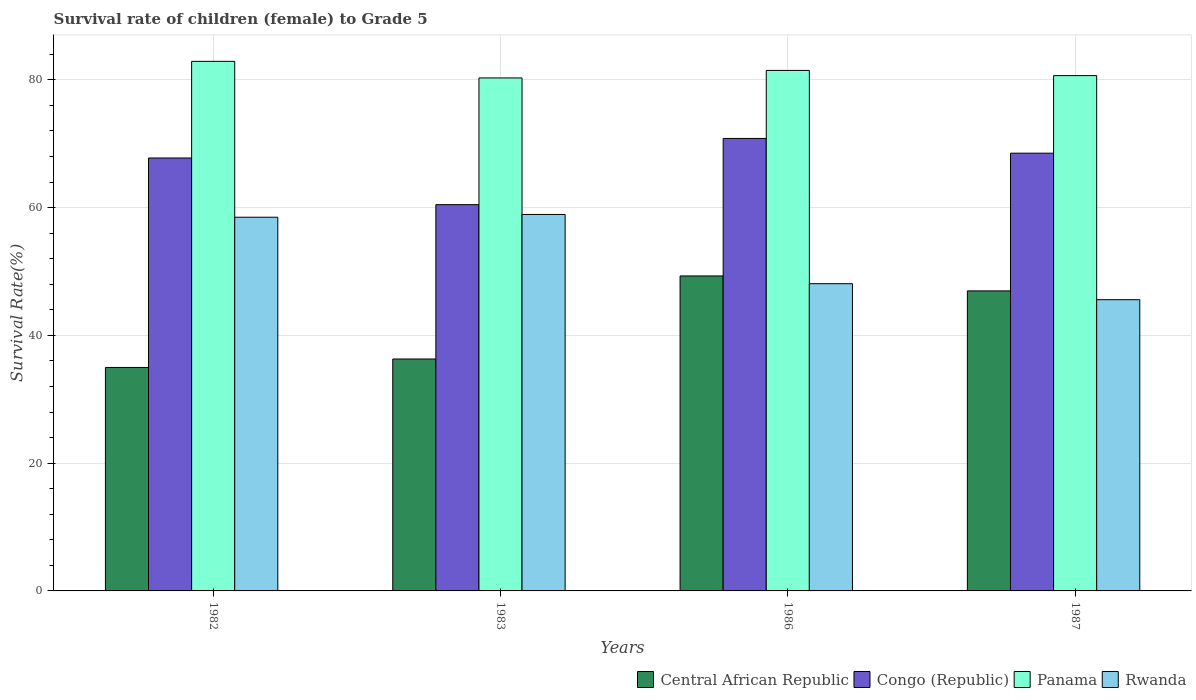How many groups of bars are there?
Ensure brevity in your answer.  4. How many bars are there on the 3rd tick from the right?
Your response must be concise. 4. What is the label of the 3rd group of bars from the left?
Provide a short and direct response. 1986. What is the survival rate of female children to grade 5 in Panama in 1983?
Provide a succinct answer. 80.3. Across all years, what is the maximum survival rate of female children to grade 5 in Panama?
Provide a short and direct response. 82.9. Across all years, what is the minimum survival rate of female children to grade 5 in Rwanda?
Ensure brevity in your answer.  45.59. In which year was the survival rate of female children to grade 5 in Central African Republic maximum?
Ensure brevity in your answer.  1986. In which year was the survival rate of female children to grade 5 in Panama minimum?
Your answer should be very brief. 1983. What is the total survival rate of female children to grade 5 in Rwanda in the graph?
Keep it short and to the point. 211.11. What is the difference between the survival rate of female children to grade 5 in Central African Republic in 1982 and that in 1987?
Offer a terse response. -11.99. What is the difference between the survival rate of female children to grade 5 in Congo (Republic) in 1986 and the survival rate of female children to grade 5 in Panama in 1982?
Your answer should be compact. -12.07. What is the average survival rate of female children to grade 5 in Rwanda per year?
Give a very brief answer. 52.78. In the year 1983, what is the difference between the survival rate of female children to grade 5 in Panama and survival rate of female children to grade 5 in Central African Republic?
Your answer should be compact. 44. In how many years, is the survival rate of female children to grade 5 in Congo (Republic) greater than 60 %?
Provide a succinct answer. 4. What is the ratio of the survival rate of female children to grade 5 in Panama in 1986 to that in 1987?
Offer a very short reply. 1.01. Is the survival rate of female children to grade 5 in Central African Republic in 1983 less than that in 1987?
Ensure brevity in your answer.  Yes. What is the difference between the highest and the second highest survival rate of female children to grade 5 in Congo (Republic)?
Your answer should be very brief. 2.31. What is the difference between the highest and the lowest survival rate of female children to grade 5 in Panama?
Provide a succinct answer. 2.6. In how many years, is the survival rate of female children to grade 5 in Rwanda greater than the average survival rate of female children to grade 5 in Rwanda taken over all years?
Provide a succinct answer. 2. Is the sum of the survival rate of female children to grade 5 in Central African Republic in 1982 and 1983 greater than the maximum survival rate of female children to grade 5 in Rwanda across all years?
Your answer should be very brief. Yes. What does the 3rd bar from the left in 1987 represents?
Provide a succinct answer. Panama. What does the 3rd bar from the right in 1983 represents?
Keep it short and to the point. Congo (Republic). Is it the case that in every year, the sum of the survival rate of female children to grade 5 in Panama and survival rate of female children to grade 5 in Rwanda is greater than the survival rate of female children to grade 5 in Central African Republic?
Give a very brief answer. Yes. How many bars are there?
Your answer should be very brief. 16. How many years are there in the graph?
Provide a succinct answer. 4. What is the difference between two consecutive major ticks on the Y-axis?
Provide a succinct answer. 20. Does the graph contain grids?
Your answer should be compact. Yes. Where does the legend appear in the graph?
Provide a succinct answer. Bottom right. What is the title of the graph?
Provide a succinct answer. Survival rate of children (female) to Grade 5. Does "Equatorial Guinea" appear as one of the legend labels in the graph?
Offer a very short reply. No. What is the label or title of the Y-axis?
Provide a succinct answer. Survival Rate(%). What is the Survival Rate(%) of Central African Republic in 1982?
Offer a terse response. 34.98. What is the Survival Rate(%) of Congo (Republic) in 1982?
Offer a terse response. 67.77. What is the Survival Rate(%) in Panama in 1982?
Your answer should be very brief. 82.9. What is the Survival Rate(%) of Rwanda in 1982?
Give a very brief answer. 58.5. What is the Survival Rate(%) in Central African Republic in 1983?
Provide a short and direct response. 36.31. What is the Survival Rate(%) of Congo (Republic) in 1983?
Provide a short and direct response. 60.47. What is the Survival Rate(%) in Panama in 1983?
Provide a succinct answer. 80.3. What is the Survival Rate(%) in Rwanda in 1983?
Give a very brief answer. 58.93. What is the Survival Rate(%) of Central African Republic in 1986?
Your response must be concise. 49.31. What is the Survival Rate(%) of Congo (Republic) in 1986?
Your answer should be compact. 70.83. What is the Survival Rate(%) in Panama in 1986?
Your response must be concise. 81.48. What is the Survival Rate(%) in Rwanda in 1986?
Your answer should be compact. 48.09. What is the Survival Rate(%) of Central African Republic in 1987?
Provide a succinct answer. 46.97. What is the Survival Rate(%) in Congo (Republic) in 1987?
Offer a very short reply. 68.53. What is the Survival Rate(%) of Panama in 1987?
Offer a terse response. 80.67. What is the Survival Rate(%) of Rwanda in 1987?
Ensure brevity in your answer.  45.59. Across all years, what is the maximum Survival Rate(%) of Central African Republic?
Give a very brief answer. 49.31. Across all years, what is the maximum Survival Rate(%) of Congo (Republic)?
Ensure brevity in your answer.  70.83. Across all years, what is the maximum Survival Rate(%) in Panama?
Offer a terse response. 82.9. Across all years, what is the maximum Survival Rate(%) in Rwanda?
Provide a short and direct response. 58.93. Across all years, what is the minimum Survival Rate(%) of Central African Republic?
Provide a succinct answer. 34.98. Across all years, what is the minimum Survival Rate(%) of Congo (Republic)?
Your response must be concise. 60.47. Across all years, what is the minimum Survival Rate(%) of Panama?
Your answer should be compact. 80.3. Across all years, what is the minimum Survival Rate(%) in Rwanda?
Offer a very short reply. 45.59. What is the total Survival Rate(%) in Central African Republic in the graph?
Your answer should be compact. 167.57. What is the total Survival Rate(%) of Congo (Republic) in the graph?
Your answer should be compact. 267.6. What is the total Survival Rate(%) in Panama in the graph?
Keep it short and to the point. 325.35. What is the total Survival Rate(%) of Rwanda in the graph?
Ensure brevity in your answer.  211.11. What is the difference between the Survival Rate(%) in Central African Republic in 1982 and that in 1983?
Ensure brevity in your answer.  -1.32. What is the difference between the Survival Rate(%) in Congo (Republic) in 1982 and that in 1983?
Your answer should be compact. 7.3. What is the difference between the Survival Rate(%) of Panama in 1982 and that in 1983?
Offer a very short reply. 2.6. What is the difference between the Survival Rate(%) in Rwanda in 1982 and that in 1983?
Ensure brevity in your answer.  -0.43. What is the difference between the Survival Rate(%) in Central African Republic in 1982 and that in 1986?
Offer a very short reply. -14.32. What is the difference between the Survival Rate(%) of Congo (Republic) in 1982 and that in 1986?
Provide a short and direct response. -3.06. What is the difference between the Survival Rate(%) in Panama in 1982 and that in 1986?
Provide a short and direct response. 1.42. What is the difference between the Survival Rate(%) of Rwanda in 1982 and that in 1986?
Offer a terse response. 10.4. What is the difference between the Survival Rate(%) in Central African Republic in 1982 and that in 1987?
Offer a terse response. -11.99. What is the difference between the Survival Rate(%) of Congo (Republic) in 1982 and that in 1987?
Ensure brevity in your answer.  -0.75. What is the difference between the Survival Rate(%) of Panama in 1982 and that in 1987?
Give a very brief answer. 2.23. What is the difference between the Survival Rate(%) of Rwanda in 1982 and that in 1987?
Keep it short and to the point. 12.91. What is the difference between the Survival Rate(%) in Central African Republic in 1983 and that in 1986?
Give a very brief answer. -13. What is the difference between the Survival Rate(%) in Congo (Republic) in 1983 and that in 1986?
Offer a terse response. -10.36. What is the difference between the Survival Rate(%) in Panama in 1983 and that in 1986?
Keep it short and to the point. -1.18. What is the difference between the Survival Rate(%) of Rwanda in 1983 and that in 1986?
Make the answer very short. 10.84. What is the difference between the Survival Rate(%) of Central African Republic in 1983 and that in 1987?
Provide a short and direct response. -10.66. What is the difference between the Survival Rate(%) of Congo (Republic) in 1983 and that in 1987?
Keep it short and to the point. -8.06. What is the difference between the Survival Rate(%) in Panama in 1983 and that in 1987?
Keep it short and to the point. -0.37. What is the difference between the Survival Rate(%) of Rwanda in 1983 and that in 1987?
Provide a short and direct response. 13.34. What is the difference between the Survival Rate(%) of Central African Republic in 1986 and that in 1987?
Offer a terse response. 2.34. What is the difference between the Survival Rate(%) of Congo (Republic) in 1986 and that in 1987?
Your answer should be compact. 2.31. What is the difference between the Survival Rate(%) in Panama in 1986 and that in 1987?
Give a very brief answer. 0.81. What is the difference between the Survival Rate(%) in Rwanda in 1986 and that in 1987?
Your response must be concise. 2.51. What is the difference between the Survival Rate(%) of Central African Republic in 1982 and the Survival Rate(%) of Congo (Republic) in 1983?
Your answer should be compact. -25.49. What is the difference between the Survival Rate(%) of Central African Republic in 1982 and the Survival Rate(%) of Panama in 1983?
Offer a very short reply. -45.32. What is the difference between the Survival Rate(%) in Central African Republic in 1982 and the Survival Rate(%) in Rwanda in 1983?
Give a very brief answer. -23.95. What is the difference between the Survival Rate(%) of Congo (Republic) in 1982 and the Survival Rate(%) of Panama in 1983?
Your answer should be very brief. -12.53. What is the difference between the Survival Rate(%) in Congo (Republic) in 1982 and the Survival Rate(%) in Rwanda in 1983?
Keep it short and to the point. 8.84. What is the difference between the Survival Rate(%) in Panama in 1982 and the Survival Rate(%) in Rwanda in 1983?
Your answer should be very brief. 23.97. What is the difference between the Survival Rate(%) in Central African Republic in 1982 and the Survival Rate(%) in Congo (Republic) in 1986?
Your response must be concise. -35.85. What is the difference between the Survival Rate(%) of Central African Republic in 1982 and the Survival Rate(%) of Panama in 1986?
Offer a terse response. -46.5. What is the difference between the Survival Rate(%) of Central African Republic in 1982 and the Survival Rate(%) of Rwanda in 1986?
Offer a terse response. -13.11. What is the difference between the Survival Rate(%) in Congo (Republic) in 1982 and the Survival Rate(%) in Panama in 1986?
Provide a short and direct response. -13.71. What is the difference between the Survival Rate(%) in Congo (Republic) in 1982 and the Survival Rate(%) in Rwanda in 1986?
Provide a short and direct response. 19.68. What is the difference between the Survival Rate(%) of Panama in 1982 and the Survival Rate(%) of Rwanda in 1986?
Make the answer very short. 34.81. What is the difference between the Survival Rate(%) in Central African Republic in 1982 and the Survival Rate(%) in Congo (Republic) in 1987?
Provide a succinct answer. -33.54. What is the difference between the Survival Rate(%) in Central African Republic in 1982 and the Survival Rate(%) in Panama in 1987?
Give a very brief answer. -45.68. What is the difference between the Survival Rate(%) in Central African Republic in 1982 and the Survival Rate(%) in Rwanda in 1987?
Offer a terse response. -10.61. What is the difference between the Survival Rate(%) in Congo (Republic) in 1982 and the Survival Rate(%) in Panama in 1987?
Give a very brief answer. -12.89. What is the difference between the Survival Rate(%) in Congo (Republic) in 1982 and the Survival Rate(%) in Rwanda in 1987?
Offer a very short reply. 22.18. What is the difference between the Survival Rate(%) in Panama in 1982 and the Survival Rate(%) in Rwanda in 1987?
Your answer should be compact. 37.31. What is the difference between the Survival Rate(%) in Central African Republic in 1983 and the Survival Rate(%) in Congo (Republic) in 1986?
Make the answer very short. -34.53. What is the difference between the Survival Rate(%) of Central African Republic in 1983 and the Survival Rate(%) of Panama in 1986?
Your answer should be very brief. -45.18. What is the difference between the Survival Rate(%) of Central African Republic in 1983 and the Survival Rate(%) of Rwanda in 1986?
Keep it short and to the point. -11.79. What is the difference between the Survival Rate(%) in Congo (Republic) in 1983 and the Survival Rate(%) in Panama in 1986?
Provide a short and direct response. -21.01. What is the difference between the Survival Rate(%) in Congo (Republic) in 1983 and the Survival Rate(%) in Rwanda in 1986?
Offer a very short reply. 12.37. What is the difference between the Survival Rate(%) in Panama in 1983 and the Survival Rate(%) in Rwanda in 1986?
Provide a succinct answer. 32.21. What is the difference between the Survival Rate(%) in Central African Republic in 1983 and the Survival Rate(%) in Congo (Republic) in 1987?
Offer a terse response. -32.22. What is the difference between the Survival Rate(%) of Central African Republic in 1983 and the Survival Rate(%) of Panama in 1987?
Provide a short and direct response. -44.36. What is the difference between the Survival Rate(%) of Central African Republic in 1983 and the Survival Rate(%) of Rwanda in 1987?
Offer a very short reply. -9.28. What is the difference between the Survival Rate(%) of Congo (Republic) in 1983 and the Survival Rate(%) of Panama in 1987?
Offer a terse response. -20.2. What is the difference between the Survival Rate(%) of Congo (Republic) in 1983 and the Survival Rate(%) of Rwanda in 1987?
Your answer should be compact. 14.88. What is the difference between the Survival Rate(%) of Panama in 1983 and the Survival Rate(%) of Rwanda in 1987?
Provide a short and direct response. 34.71. What is the difference between the Survival Rate(%) of Central African Republic in 1986 and the Survival Rate(%) of Congo (Republic) in 1987?
Give a very brief answer. -19.22. What is the difference between the Survival Rate(%) of Central African Republic in 1986 and the Survival Rate(%) of Panama in 1987?
Ensure brevity in your answer.  -31.36. What is the difference between the Survival Rate(%) in Central African Republic in 1986 and the Survival Rate(%) in Rwanda in 1987?
Ensure brevity in your answer.  3.72. What is the difference between the Survival Rate(%) in Congo (Republic) in 1986 and the Survival Rate(%) in Panama in 1987?
Offer a terse response. -9.84. What is the difference between the Survival Rate(%) of Congo (Republic) in 1986 and the Survival Rate(%) of Rwanda in 1987?
Ensure brevity in your answer.  25.24. What is the difference between the Survival Rate(%) of Panama in 1986 and the Survival Rate(%) of Rwanda in 1987?
Give a very brief answer. 35.89. What is the average Survival Rate(%) of Central African Republic per year?
Offer a terse response. 41.89. What is the average Survival Rate(%) of Congo (Republic) per year?
Ensure brevity in your answer.  66.9. What is the average Survival Rate(%) of Panama per year?
Provide a short and direct response. 81.34. What is the average Survival Rate(%) in Rwanda per year?
Offer a terse response. 52.78. In the year 1982, what is the difference between the Survival Rate(%) of Central African Republic and Survival Rate(%) of Congo (Republic)?
Provide a succinct answer. -32.79. In the year 1982, what is the difference between the Survival Rate(%) of Central African Republic and Survival Rate(%) of Panama?
Offer a terse response. -47.92. In the year 1982, what is the difference between the Survival Rate(%) of Central African Republic and Survival Rate(%) of Rwanda?
Provide a succinct answer. -23.52. In the year 1982, what is the difference between the Survival Rate(%) of Congo (Republic) and Survival Rate(%) of Panama?
Your answer should be compact. -15.13. In the year 1982, what is the difference between the Survival Rate(%) of Congo (Republic) and Survival Rate(%) of Rwanda?
Give a very brief answer. 9.27. In the year 1982, what is the difference between the Survival Rate(%) in Panama and Survival Rate(%) in Rwanda?
Offer a terse response. 24.4. In the year 1983, what is the difference between the Survival Rate(%) in Central African Republic and Survival Rate(%) in Congo (Republic)?
Your response must be concise. -24.16. In the year 1983, what is the difference between the Survival Rate(%) of Central African Republic and Survival Rate(%) of Panama?
Offer a very short reply. -44. In the year 1983, what is the difference between the Survival Rate(%) of Central African Republic and Survival Rate(%) of Rwanda?
Ensure brevity in your answer.  -22.62. In the year 1983, what is the difference between the Survival Rate(%) of Congo (Republic) and Survival Rate(%) of Panama?
Ensure brevity in your answer.  -19.83. In the year 1983, what is the difference between the Survival Rate(%) in Congo (Republic) and Survival Rate(%) in Rwanda?
Keep it short and to the point. 1.54. In the year 1983, what is the difference between the Survival Rate(%) of Panama and Survival Rate(%) of Rwanda?
Offer a very short reply. 21.37. In the year 1986, what is the difference between the Survival Rate(%) in Central African Republic and Survival Rate(%) in Congo (Republic)?
Keep it short and to the point. -21.52. In the year 1986, what is the difference between the Survival Rate(%) of Central African Republic and Survival Rate(%) of Panama?
Offer a terse response. -32.17. In the year 1986, what is the difference between the Survival Rate(%) in Central African Republic and Survival Rate(%) in Rwanda?
Make the answer very short. 1.21. In the year 1986, what is the difference between the Survival Rate(%) in Congo (Republic) and Survival Rate(%) in Panama?
Offer a terse response. -10.65. In the year 1986, what is the difference between the Survival Rate(%) in Congo (Republic) and Survival Rate(%) in Rwanda?
Keep it short and to the point. 22.74. In the year 1986, what is the difference between the Survival Rate(%) of Panama and Survival Rate(%) of Rwanda?
Keep it short and to the point. 33.39. In the year 1987, what is the difference between the Survival Rate(%) in Central African Republic and Survival Rate(%) in Congo (Republic)?
Provide a succinct answer. -21.56. In the year 1987, what is the difference between the Survival Rate(%) of Central African Republic and Survival Rate(%) of Panama?
Your answer should be very brief. -33.7. In the year 1987, what is the difference between the Survival Rate(%) of Central African Republic and Survival Rate(%) of Rwanda?
Your answer should be compact. 1.38. In the year 1987, what is the difference between the Survival Rate(%) of Congo (Republic) and Survival Rate(%) of Panama?
Make the answer very short. -12.14. In the year 1987, what is the difference between the Survival Rate(%) in Congo (Republic) and Survival Rate(%) in Rwanda?
Make the answer very short. 22.94. In the year 1987, what is the difference between the Survival Rate(%) of Panama and Survival Rate(%) of Rwanda?
Provide a short and direct response. 35.08. What is the ratio of the Survival Rate(%) in Central African Republic in 1982 to that in 1983?
Provide a succinct answer. 0.96. What is the ratio of the Survival Rate(%) of Congo (Republic) in 1982 to that in 1983?
Your answer should be compact. 1.12. What is the ratio of the Survival Rate(%) in Panama in 1982 to that in 1983?
Make the answer very short. 1.03. What is the ratio of the Survival Rate(%) of Central African Republic in 1982 to that in 1986?
Keep it short and to the point. 0.71. What is the ratio of the Survival Rate(%) of Congo (Republic) in 1982 to that in 1986?
Ensure brevity in your answer.  0.96. What is the ratio of the Survival Rate(%) in Panama in 1982 to that in 1986?
Keep it short and to the point. 1.02. What is the ratio of the Survival Rate(%) in Rwanda in 1982 to that in 1986?
Make the answer very short. 1.22. What is the ratio of the Survival Rate(%) of Central African Republic in 1982 to that in 1987?
Keep it short and to the point. 0.74. What is the ratio of the Survival Rate(%) of Congo (Republic) in 1982 to that in 1987?
Provide a short and direct response. 0.99. What is the ratio of the Survival Rate(%) of Panama in 1982 to that in 1987?
Your answer should be compact. 1.03. What is the ratio of the Survival Rate(%) in Rwanda in 1982 to that in 1987?
Keep it short and to the point. 1.28. What is the ratio of the Survival Rate(%) in Central African Republic in 1983 to that in 1986?
Your response must be concise. 0.74. What is the ratio of the Survival Rate(%) of Congo (Republic) in 1983 to that in 1986?
Offer a terse response. 0.85. What is the ratio of the Survival Rate(%) in Panama in 1983 to that in 1986?
Your response must be concise. 0.99. What is the ratio of the Survival Rate(%) of Rwanda in 1983 to that in 1986?
Offer a terse response. 1.23. What is the ratio of the Survival Rate(%) of Central African Republic in 1983 to that in 1987?
Keep it short and to the point. 0.77. What is the ratio of the Survival Rate(%) in Congo (Republic) in 1983 to that in 1987?
Offer a very short reply. 0.88. What is the ratio of the Survival Rate(%) in Panama in 1983 to that in 1987?
Your answer should be compact. 1. What is the ratio of the Survival Rate(%) of Rwanda in 1983 to that in 1987?
Provide a succinct answer. 1.29. What is the ratio of the Survival Rate(%) of Central African Republic in 1986 to that in 1987?
Ensure brevity in your answer.  1.05. What is the ratio of the Survival Rate(%) of Congo (Republic) in 1986 to that in 1987?
Keep it short and to the point. 1.03. What is the ratio of the Survival Rate(%) of Panama in 1986 to that in 1987?
Make the answer very short. 1.01. What is the ratio of the Survival Rate(%) of Rwanda in 1986 to that in 1987?
Offer a terse response. 1.05. What is the difference between the highest and the second highest Survival Rate(%) in Central African Republic?
Your response must be concise. 2.34. What is the difference between the highest and the second highest Survival Rate(%) of Congo (Republic)?
Provide a short and direct response. 2.31. What is the difference between the highest and the second highest Survival Rate(%) of Panama?
Give a very brief answer. 1.42. What is the difference between the highest and the second highest Survival Rate(%) of Rwanda?
Your answer should be compact. 0.43. What is the difference between the highest and the lowest Survival Rate(%) of Central African Republic?
Provide a short and direct response. 14.32. What is the difference between the highest and the lowest Survival Rate(%) of Congo (Republic)?
Give a very brief answer. 10.36. What is the difference between the highest and the lowest Survival Rate(%) of Panama?
Keep it short and to the point. 2.6. What is the difference between the highest and the lowest Survival Rate(%) of Rwanda?
Your answer should be very brief. 13.34. 